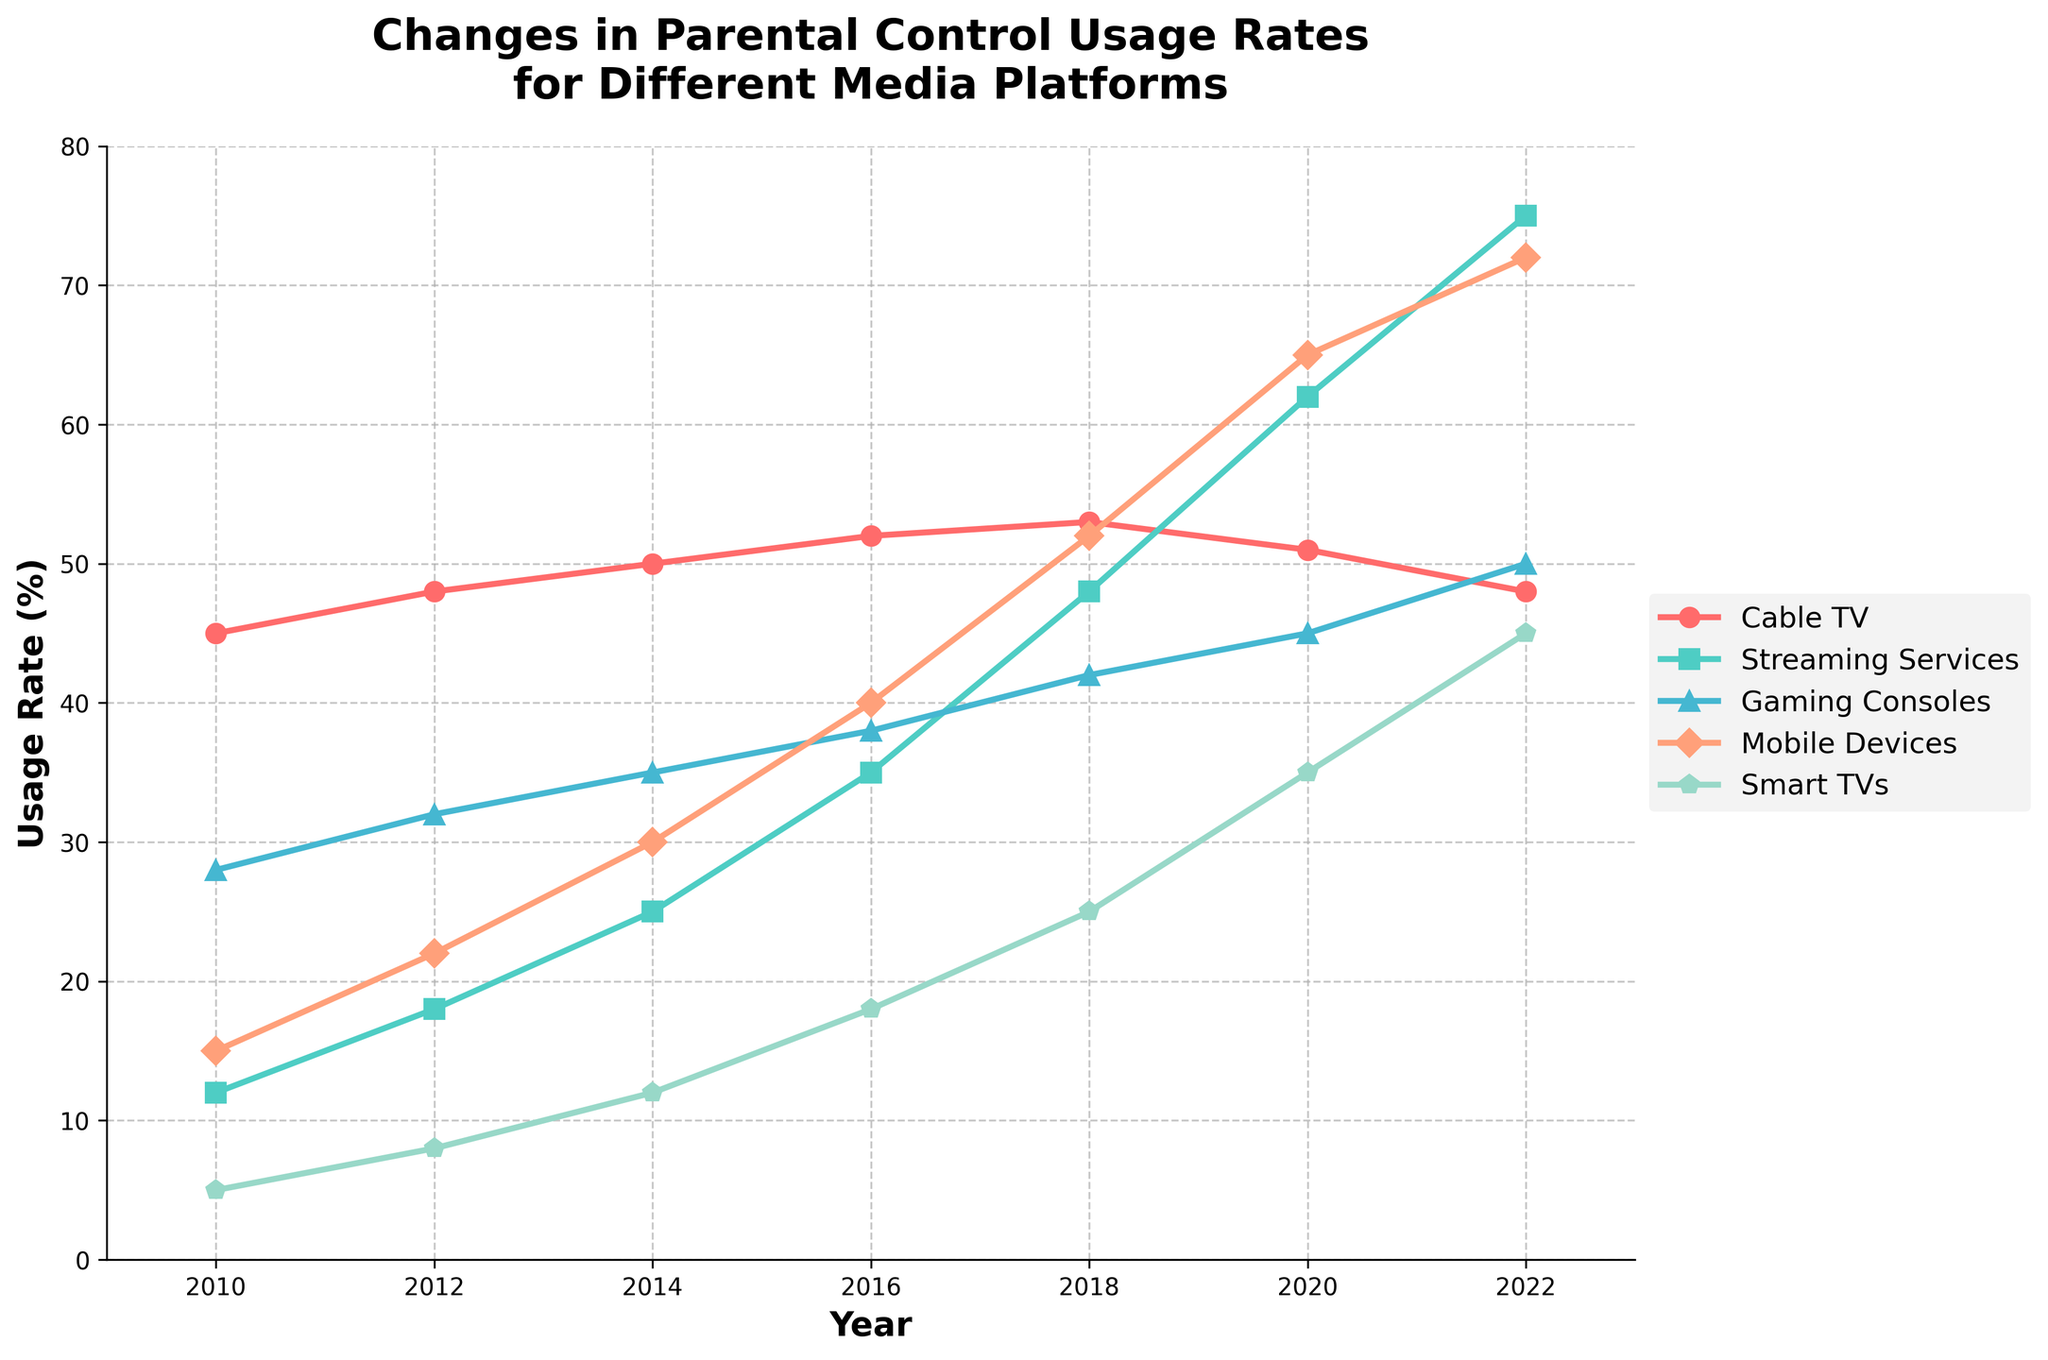What year had the highest usage rate for mobile devices? Look at the line representing mobile devices (likely the orange line) and identify the peak point. The highest usage rate for mobile devices is in 2022 where it reaches 72%.
Answer: 2022 Which media platform showed the largest increase in parental control usage from 2010 to 2022? Compare the values for each platform from 2010 to 2022. Streaming Services increased from 12% to 75%, which is the largest increase of 63 percentage points.
Answer: Streaming Services In what years did Smart TVs surpass Cable TV in parental control usage rates? Examine both lines representing Smart TVs and Cable TV. Smart TVs surpass Cable TV in the years 2018, 2020, and 2022.
Answer: 2018, 2020, and 2022 What's the average parental control usage rate for Gaming Consoles across all years in the dataset? Sum the gaming consoles usage rates and divide by the number of years. (28 + 32 + 35 + 38 + 42 + 45 + 50)/7 = 270/7 ≈ 38.57%
Answer: 38.57% Which platform had the least change in parental control usage rate over the period from 2010 to 2022? Evaluate the differences between the 2010 and 2022 values for each platform. Cable TV went from 45% to 48%, a difference of only 3 percentage points, which is the least change.
Answer: Cable TV In 2014, what was the difference in usage rates between Smart TVs and Gaming Consoles? Subtract the usage rate of Gaming Consoles from Smart TVs in 2014. 12% (Smart TVs) - 35% (Gaming Consoles) = -23 percentage points.
Answer: -23 percentage points By how much did the usage rate of Streaming Services increase between 2016 and 2020? Subtract the 2016 value of Streaming Services from the 2020 value. 62% (2020) - 35% (2016) = 27 percentage points.
Answer: 27 percentage points Which platform saw a steady increase in usage rate every measured year? Look at the trend lines and identify the platform with continuous increases without any dips. Streaming Services show a steady increase each year from 2010 to 2022.
Answer: Streaming Services In which year did Mobile Devices first surpass Gaming Consoles in usage rate? Locate the point where the line for Mobile Devices intersects and then surpasses the line for Gaming Consoles. This first occurs in 2016 for Mobile Devices surpassing Gaming Consoles.
Answer: 2016 